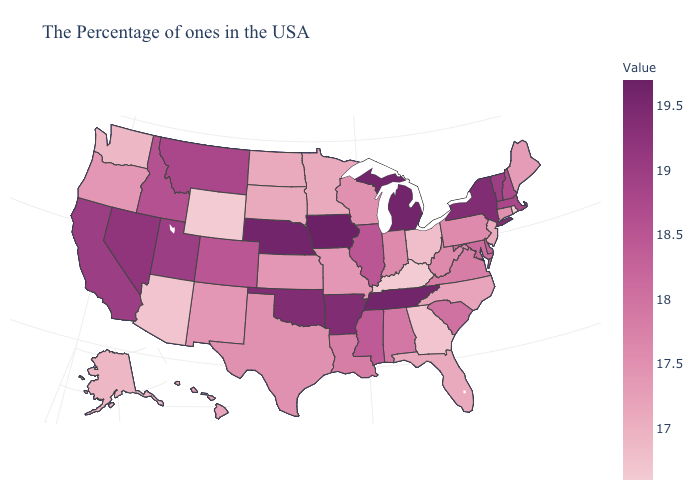Which states have the lowest value in the West?
Keep it brief. Wyoming. Does Nevada have the highest value in the West?
Answer briefly. Yes. Among the states that border Massachusetts , which have the highest value?
Answer briefly. New York. Which states have the lowest value in the West?
Give a very brief answer. Wyoming. Which states have the lowest value in the South?
Answer briefly. Kentucky. Does Iowa have the lowest value in the MidWest?
Answer briefly. No. 